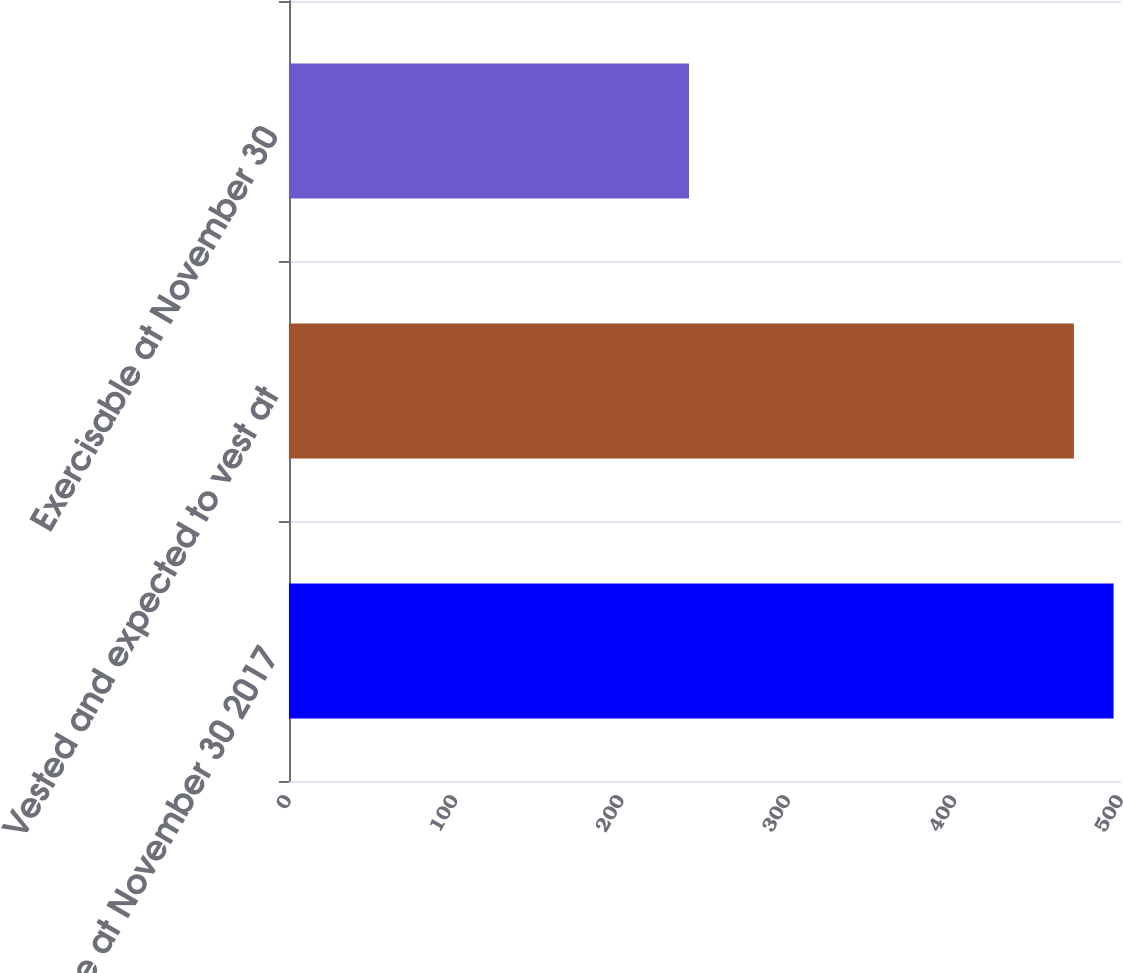Convert chart. <chart><loc_0><loc_0><loc_500><loc_500><bar_chart><fcel>Balance at November 30 2017<fcel>Vested and expected to vest at<fcel>Exercisable at November 30<nl><fcel>495.53<fcel>471.7<fcel>240.4<nl></chart> 